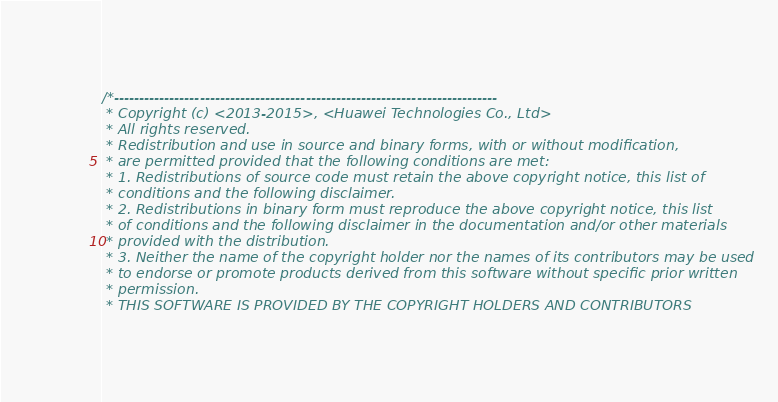Convert code to text. <code><loc_0><loc_0><loc_500><loc_500><_C_>/*----------------------------------------------------------------------------
 * Copyright (c) <2013-2015>, <Huawei Technologies Co., Ltd>
 * All rights reserved.
 * Redistribution and use in source and binary forms, with or without modification,
 * are permitted provided that the following conditions are met:
 * 1. Redistributions of source code must retain the above copyright notice, this list of
 * conditions and the following disclaimer.
 * 2. Redistributions in binary form must reproduce the above copyright notice, this list
 * of conditions and the following disclaimer in the documentation and/or other materials
 * provided with the distribution.
 * 3. Neither the name of the copyright holder nor the names of its contributors may be used
 * to endorse or promote products derived from this software without specific prior written
 * permission.
 * THIS SOFTWARE IS PROVIDED BY THE COPYRIGHT HOLDERS AND CONTRIBUTORS</code> 